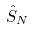<formula> <loc_0><loc_0><loc_500><loc_500>\hat { S } _ { N }</formula> 